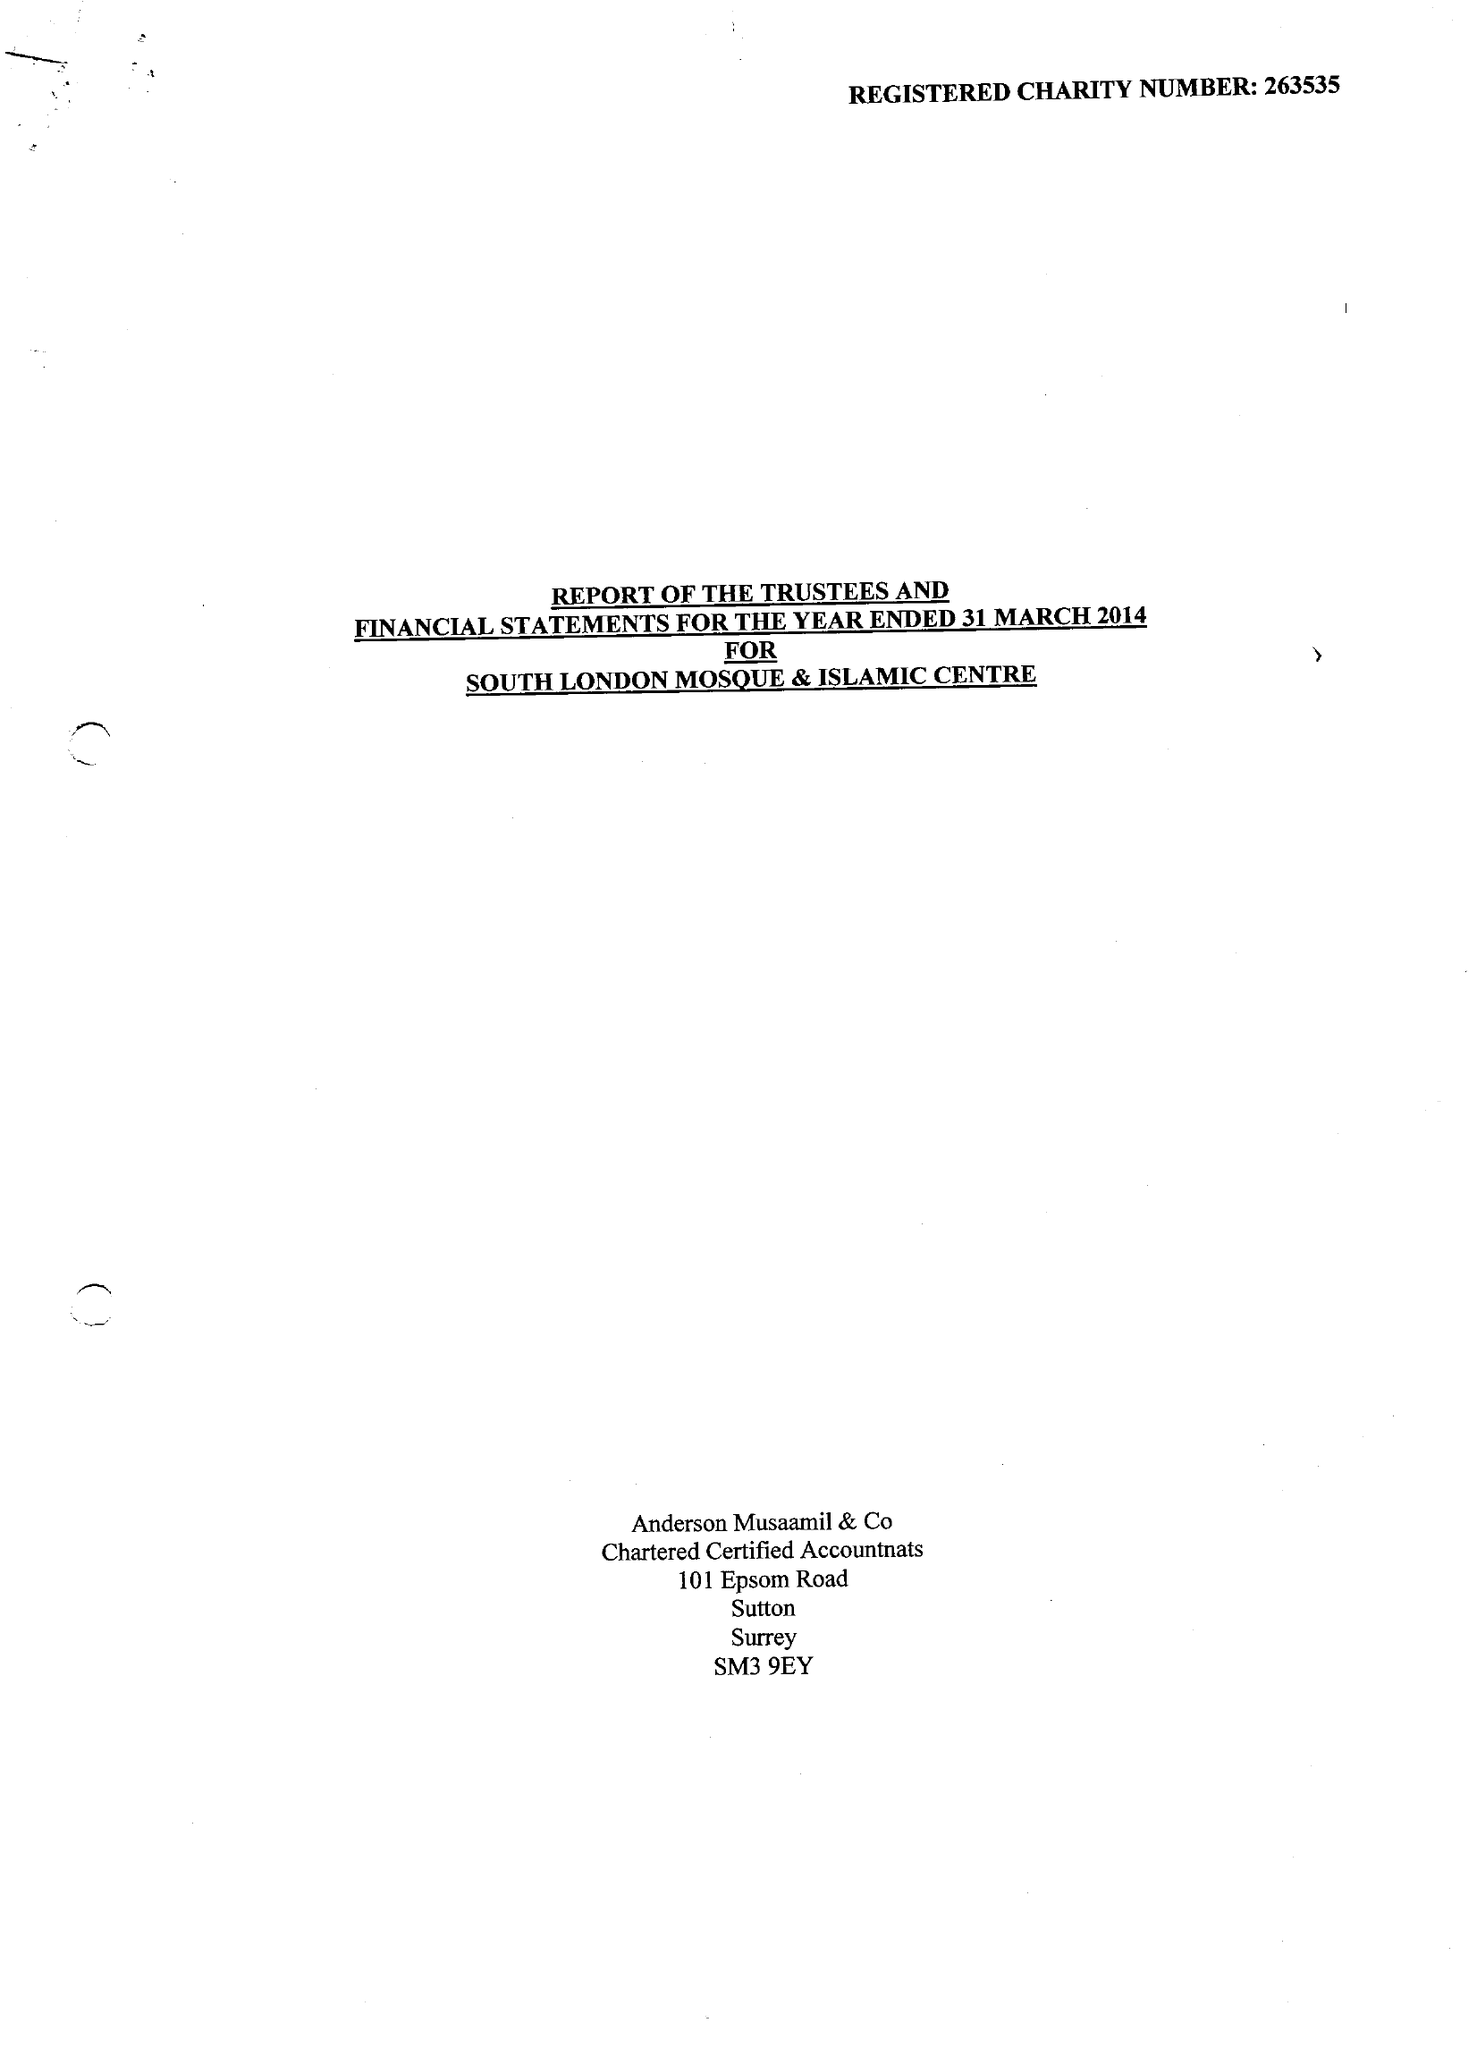What is the value for the charity_number?
Answer the question using a single word or phrase. 263535 